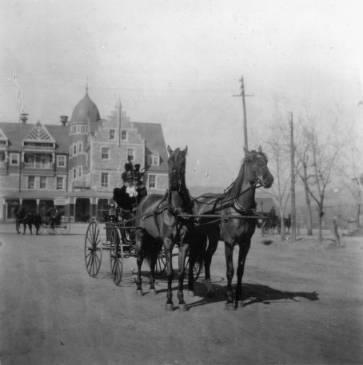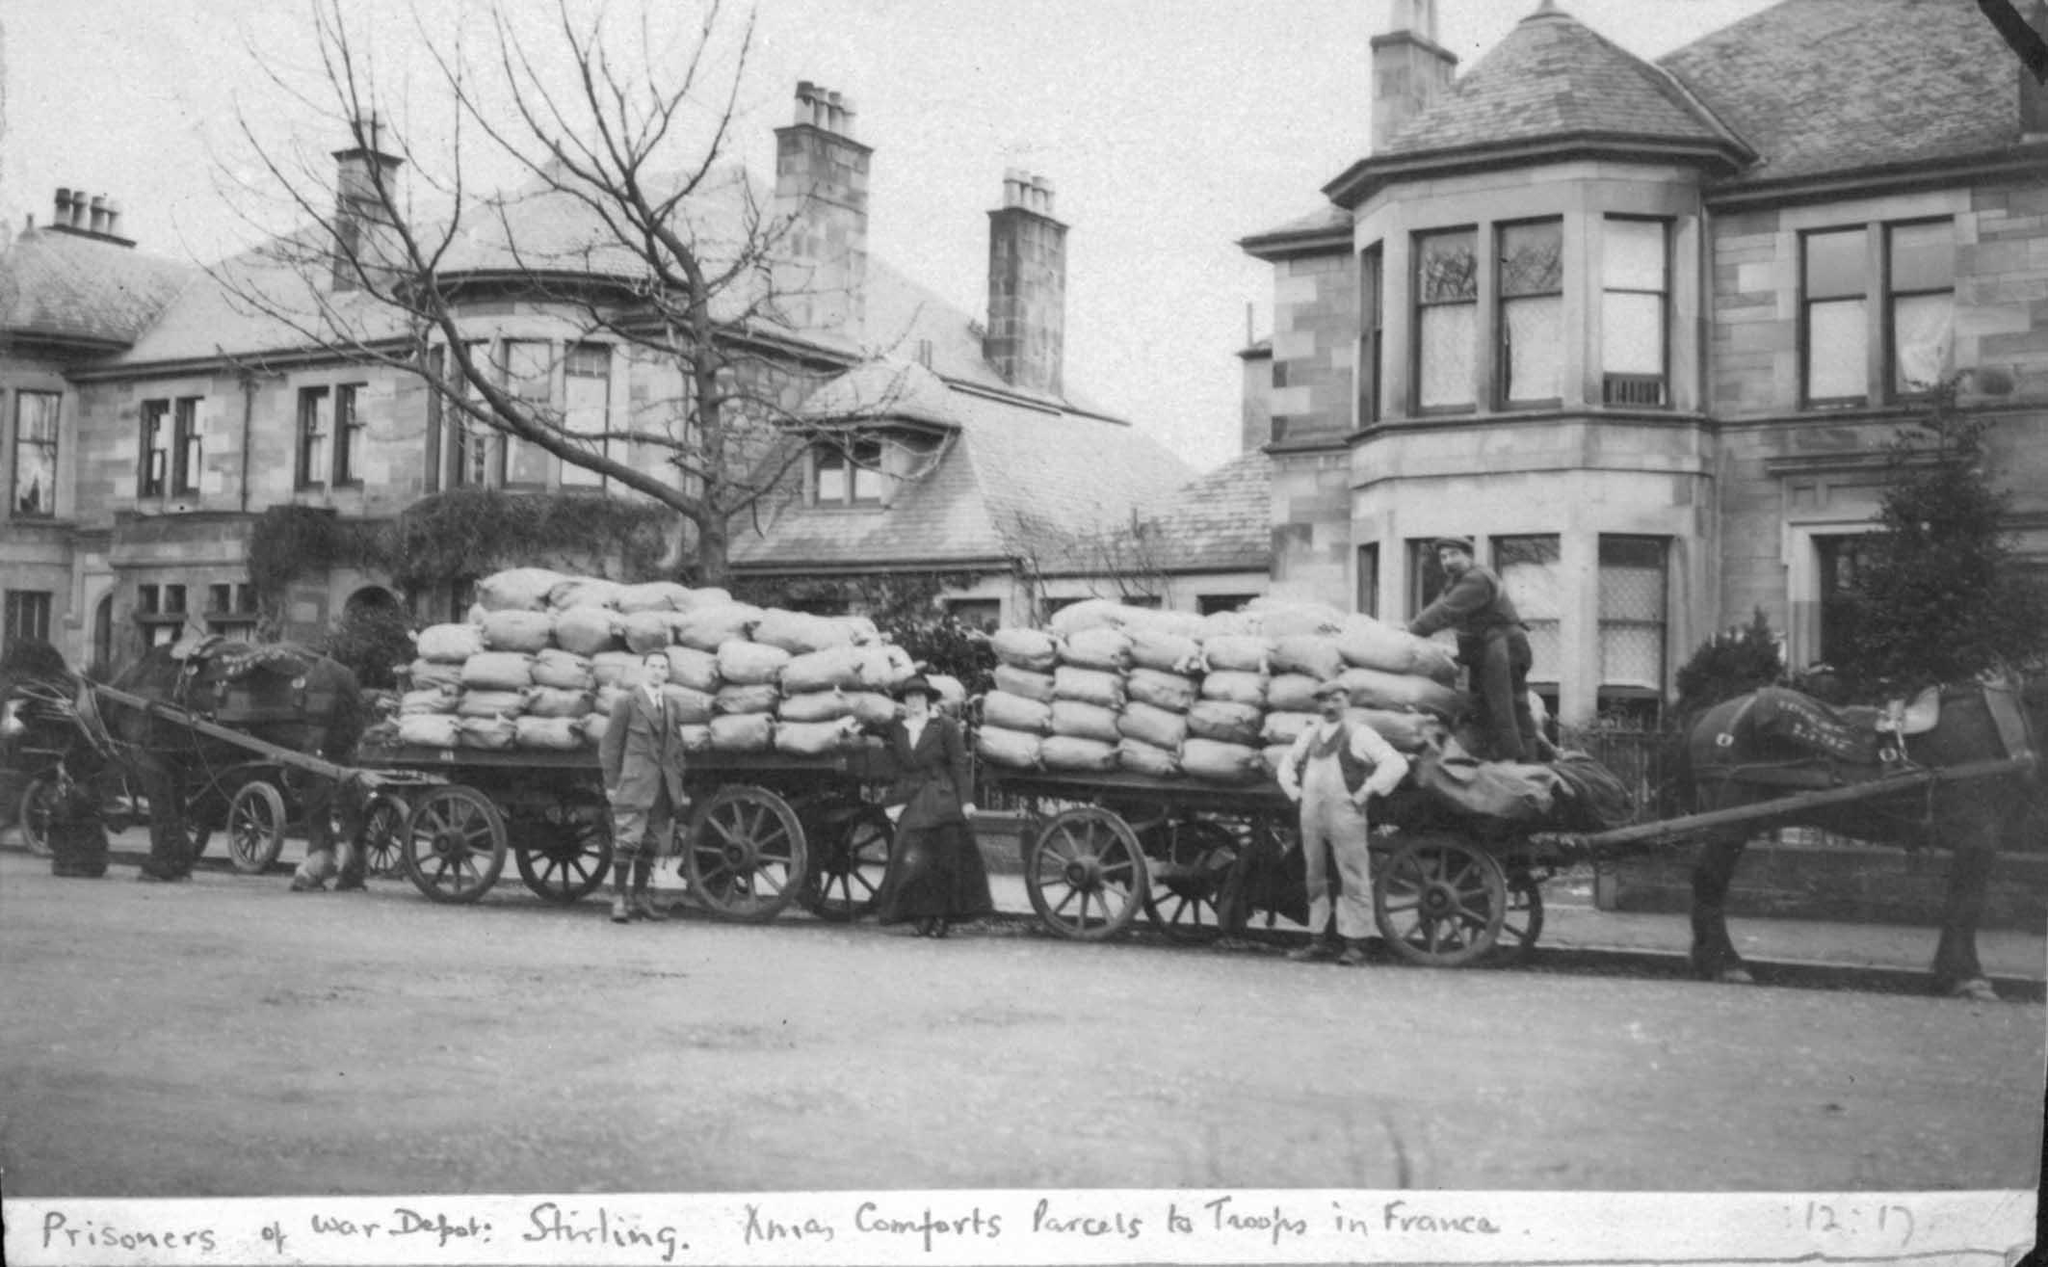The first image is the image on the left, the second image is the image on the right. For the images displayed, is the sentence "In one image, two people are sitting in a carriage with only two large wheels, which is pulled by one horse." factually correct? Answer yes or no. No. 